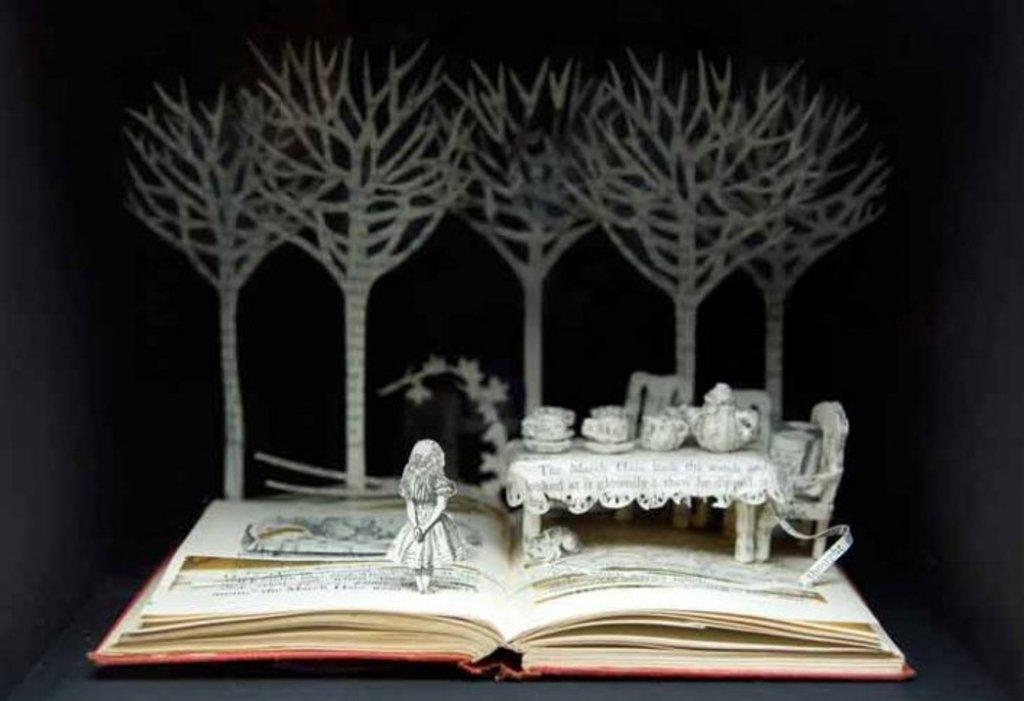What is one object visible in the image? There is a book in the image. What type of art can be seen in the image? There is paper art in the image. What piece of furniture is present in the image? There is a table in the image. What type of seating is visible in the image? There are chairs in the image. Who is present in the image? There is a girl in the image. What can be seen in the background of the image? There are trees in the background of the image. What force is being applied to the line in the image? There is no line present in the image, so no force can be applied to it. What is the girl's reaction to the surprise in the image? There is no surprise present in the image, so the girl's reaction cannot be determined. 